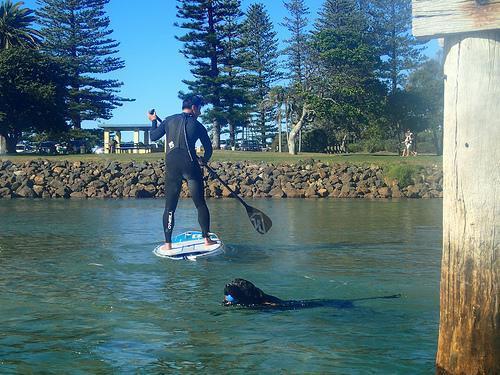How many dogs are in the photo?
Give a very brief answer. 1. 